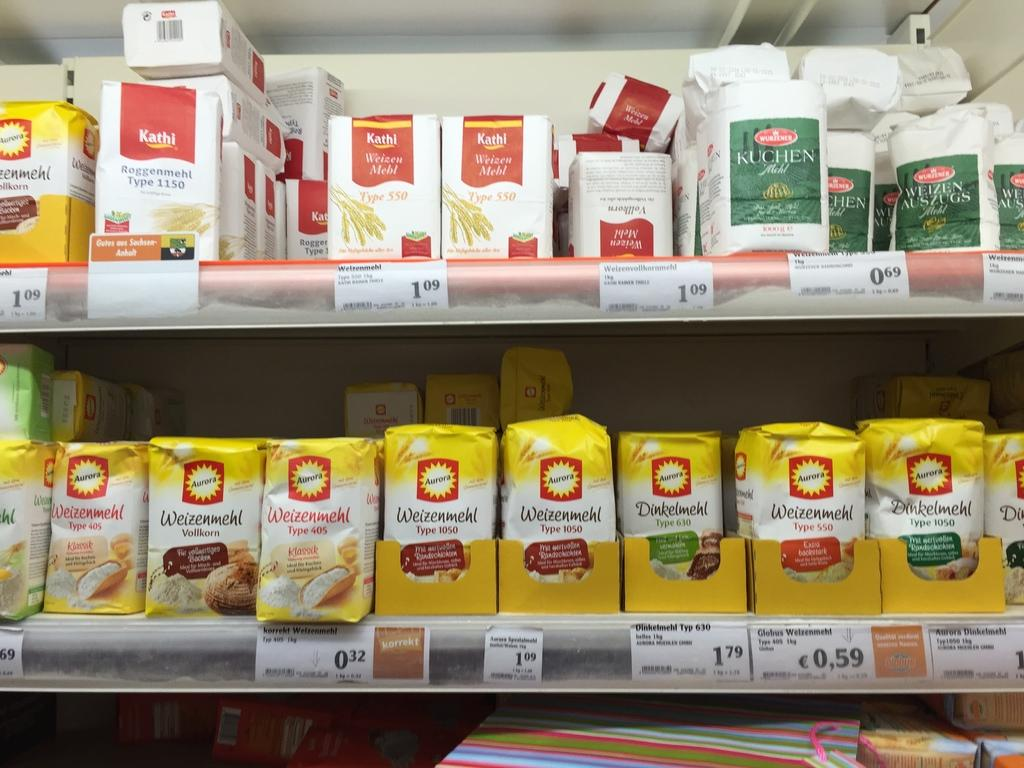<image>
Write a terse but informative summary of the picture. Different brands and types of flour are stacked on two shelves. 